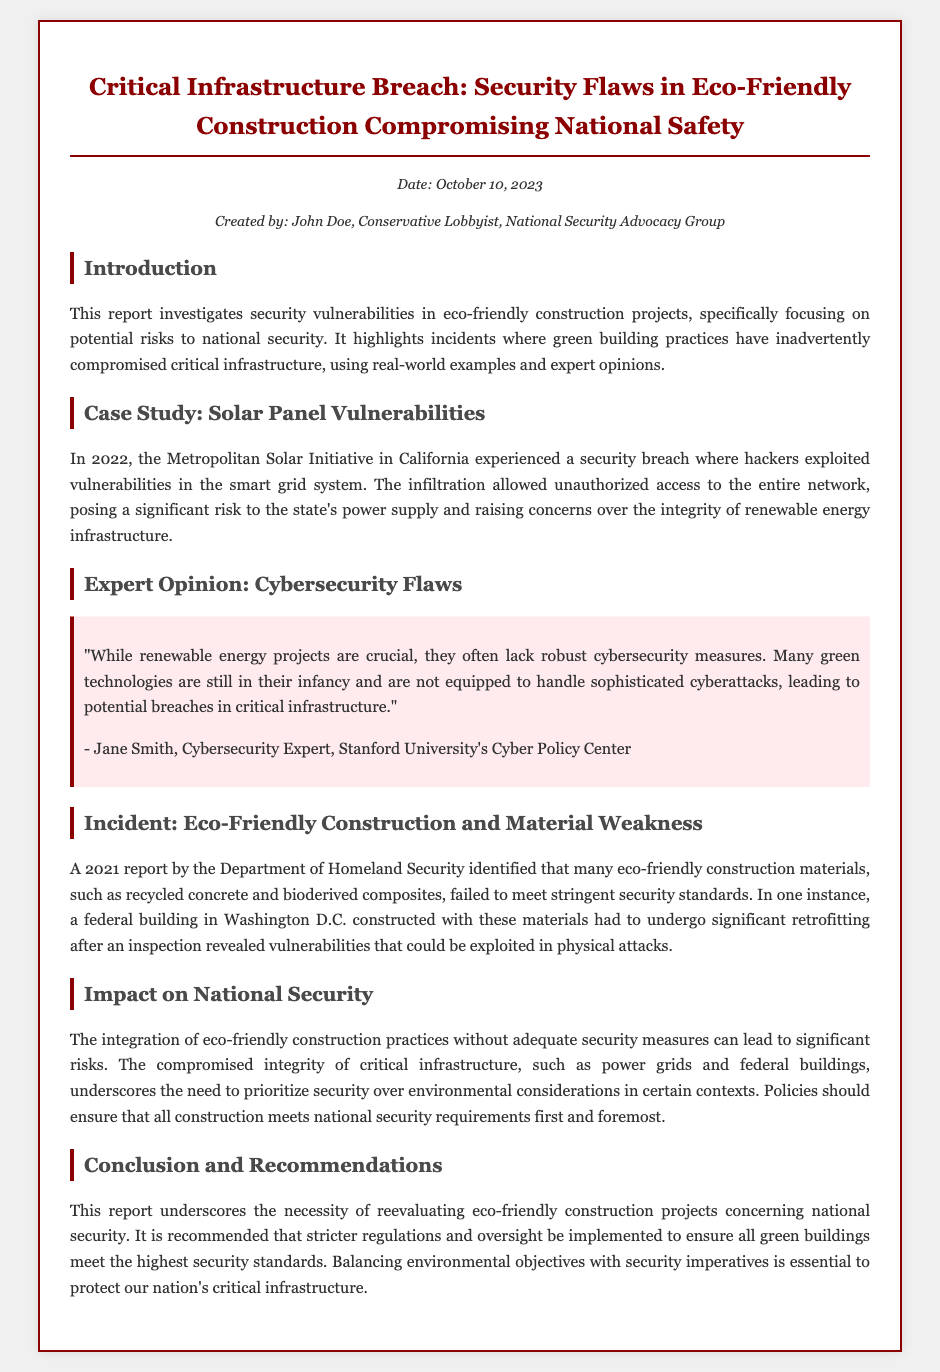what is the title of the report? The title of the report is prominently displayed at the top of the document, summarizing the focus of the investigation.
Answer: Critical Infrastructure Breach: Security Flaws in Eco-Friendly Construction Compromising National Safety who created the report? The author's name and affiliation are provided in the meta section of the document, indicating who authored the report.
Answer: John Doe, Conservative Lobbyist, National Security Advocacy Group what year did the solar panel breach occur? The incident is specified in a case study section detailing a specific breach event, including its timing.
Answer: 2022 which organization identified construction material weaknesses? The document cites a specific organization that conducted a report revealing vulnerabilities in materials used in eco-friendly construction.
Answer: Department of Homeland Security name one issue highlighted in the expert opinion. The expert's opinion discusses challenges related to certain aspects of eco-friendly technologies in the context of cybersecurity.
Answer: Lack of robust cybersecurity measures what did the 2021 report lead to regarding the federal building? The section mentions the consequences of findings from the report in regards to infrastructure management and necessary actions taken.
Answer: Significant retrofitting what needs to be prioritized according to the report’s conclusions? The conclusion section emphasizes what should take precedence in the context of construction and infrastructure policies.
Answer: Security over environmental considerations how many case studies are mentioned in the report? The structure of the document is analyzed to determine the number of distinct case studies presented.
Answer: One 